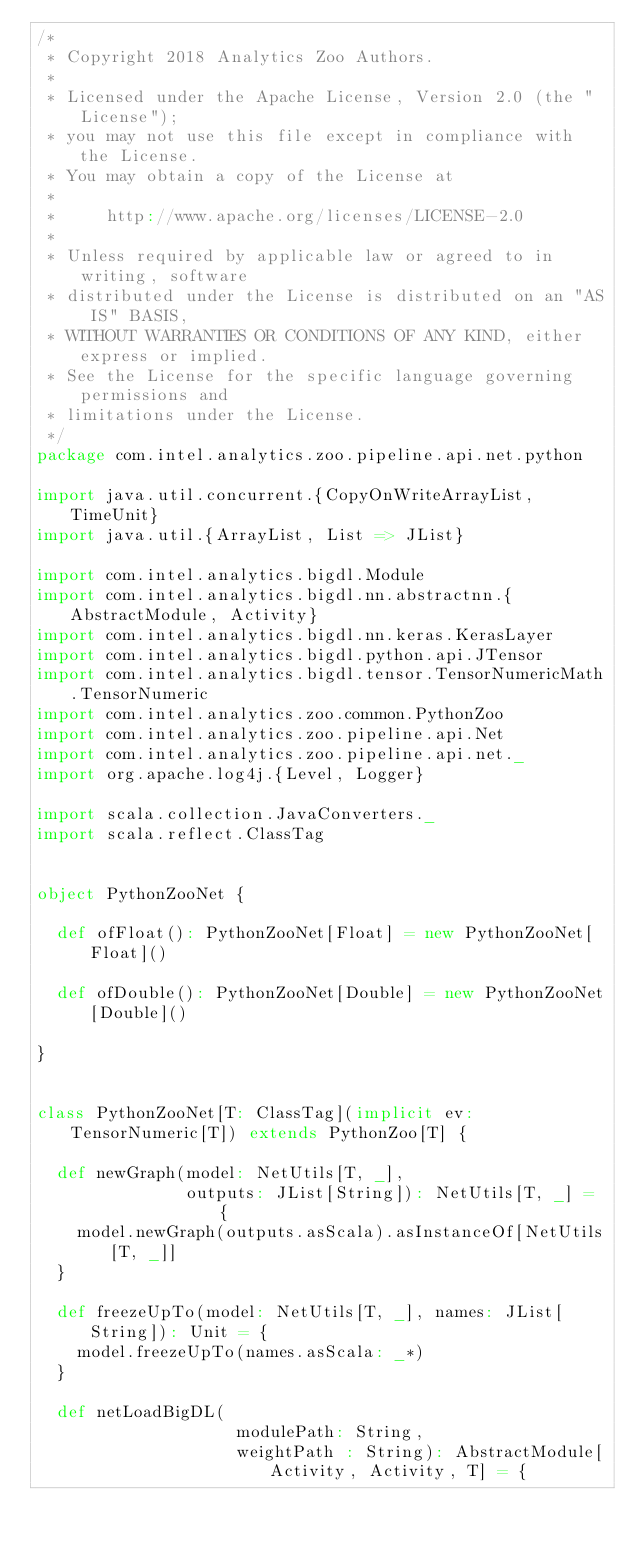<code> <loc_0><loc_0><loc_500><loc_500><_Scala_>/*
 * Copyright 2018 Analytics Zoo Authors.
 *
 * Licensed under the Apache License, Version 2.0 (the "License");
 * you may not use this file except in compliance with the License.
 * You may obtain a copy of the License at
 *
 *     http://www.apache.org/licenses/LICENSE-2.0
 *
 * Unless required by applicable law or agreed to in writing, software
 * distributed under the License is distributed on an "AS IS" BASIS,
 * WITHOUT WARRANTIES OR CONDITIONS OF ANY KIND, either express or implied.
 * See the License for the specific language governing permissions and
 * limitations under the License.
 */
package com.intel.analytics.zoo.pipeline.api.net.python

import java.util.concurrent.{CopyOnWriteArrayList, TimeUnit}
import java.util.{ArrayList, List => JList}

import com.intel.analytics.bigdl.Module
import com.intel.analytics.bigdl.nn.abstractnn.{AbstractModule, Activity}
import com.intel.analytics.bigdl.nn.keras.KerasLayer
import com.intel.analytics.bigdl.python.api.JTensor
import com.intel.analytics.bigdl.tensor.TensorNumericMath.TensorNumeric
import com.intel.analytics.zoo.common.PythonZoo
import com.intel.analytics.zoo.pipeline.api.Net
import com.intel.analytics.zoo.pipeline.api.net._
import org.apache.log4j.{Level, Logger}

import scala.collection.JavaConverters._
import scala.reflect.ClassTag


object PythonZooNet {

  def ofFloat(): PythonZooNet[Float] = new PythonZooNet[Float]()

  def ofDouble(): PythonZooNet[Double] = new PythonZooNet[Double]()

}


class PythonZooNet[T: ClassTag](implicit ev: TensorNumeric[T]) extends PythonZoo[T] {

  def newGraph(model: NetUtils[T, _],
               outputs: JList[String]): NetUtils[T, _] = {
    model.newGraph(outputs.asScala).asInstanceOf[NetUtils[T, _]]
  }

  def freezeUpTo(model: NetUtils[T, _], names: JList[String]): Unit = {
    model.freezeUpTo(names.asScala: _*)
  }

  def netLoadBigDL(
                    modulePath: String,
                    weightPath : String): AbstractModule[Activity, Activity, T] = {</code> 